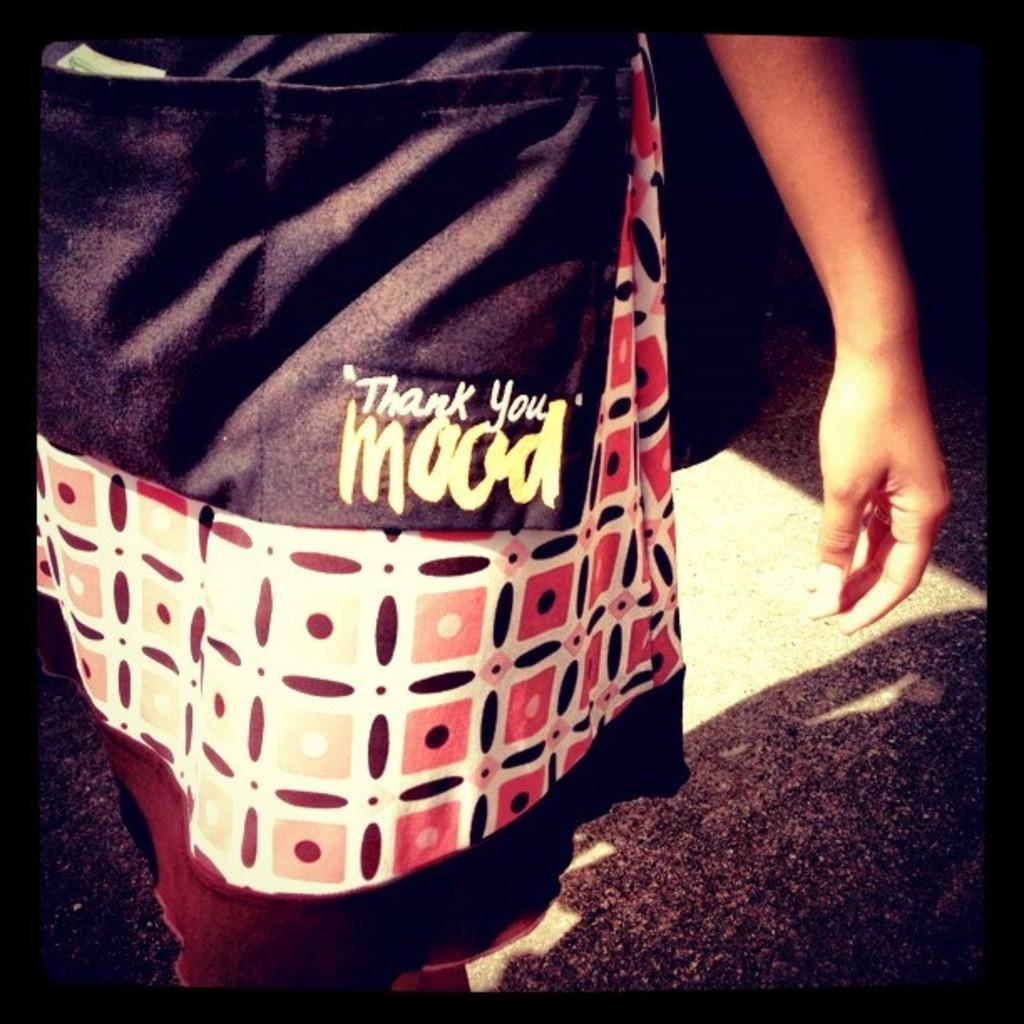What is present in the image? There is a person in the image. Can you describe the person's face in the image? The person's face is not visible in the image. What can be seen regarding the person's attire in the image? The person is wearing clothes in the image. What type of board can be seen being copied by the person in the image? There is no board or copying activity present in the image. How many cars are visible in the image? There are no cars visible in the image. 